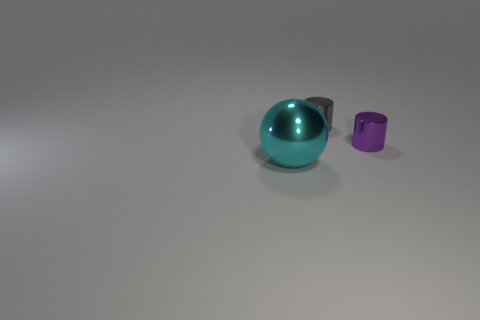What number of green rubber cubes are the same size as the gray cylinder?
Give a very brief answer. 0. What material is the object that is behind the big sphere and in front of the tiny gray shiny thing?
Your response must be concise. Metal. There is a tiny gray cylinder; what number of objects are on the right side of it?
Provide a short and direct response. 1. Do the big cyan shiny thing and the small object that is in front of the gray cylinder have the same shape?
Offer a terse response. No. Is there another tiny gray shiny object that has the same shape as the small gray thing?
Provide a short and direct response. No. There is a tiny object in front of the small thing to the left of the small purple object; what is its shape?
Provide a succinct answer. Cylinder. What is the shape of the small shiny thing behind the purple cylinder?
Provide a succinct answer. Cylinder. There is a object on the left side of the small gray cylinder; is it the same color as the shiny cylinder behind the small purple thing?
Your answer should be very brief. No. What number of metallic things are to the left of the small gray thing and right of the big shiny thing?
Provide a succinct answer. 0. What size is the gray cylinder that is made of the same material as the large object?
Provide a short and direct response. Small. 